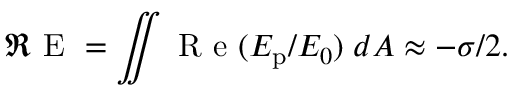Convert formula to latex. <formula><loc_0><loc_0><loc_500><loc_500>\Re E = \iint R e ( E _ { p } / E _ { 0 } ) \, d A \approx - \sigma / 2 .</formula> 